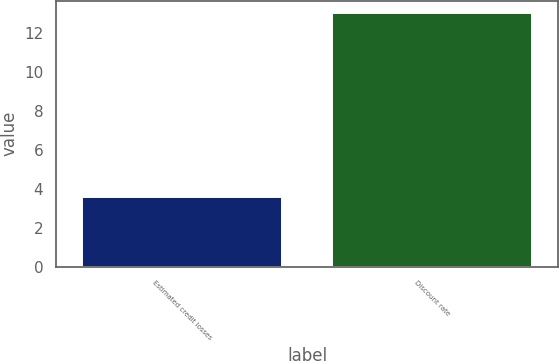Convert chart to OTSL. <chart><loc_0><loc_0><loc_500><loc_500><bar_chart><fcel>Estimated credit losses<fcel>Discount rate<nl><fcel>3.6<fcel>13.03<nl></chart> 